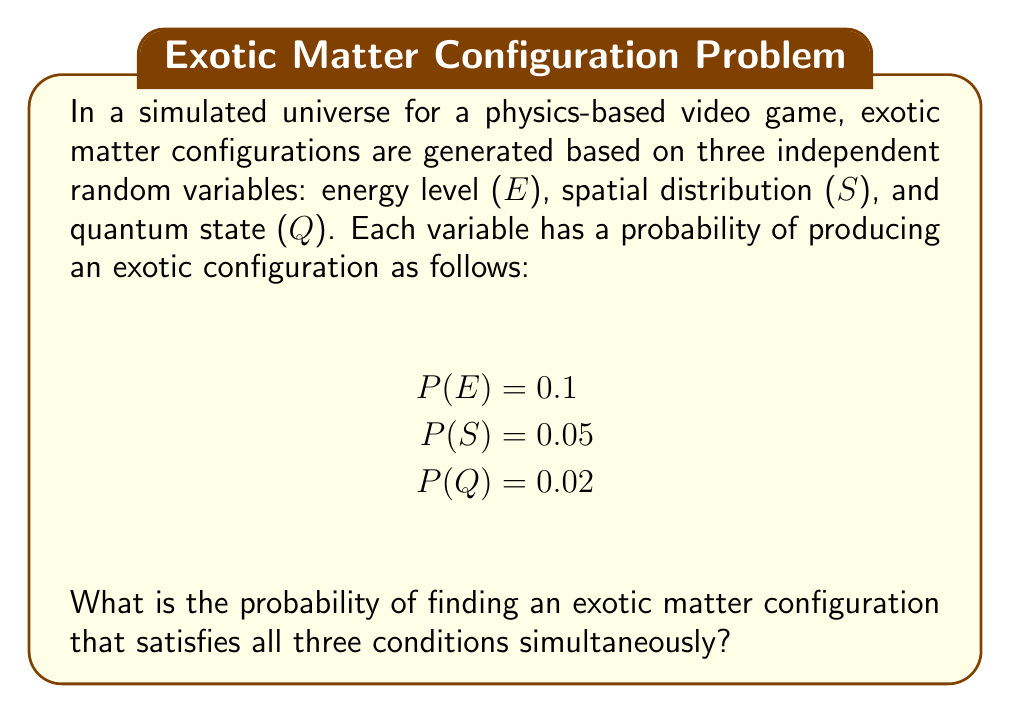Show me your answer to this math problem. To solve this problem, we'll follow these steps:

1. Recognize that we're dealing with independent events.
2. Recall the multiplication rule for independent events.
3. Apply the rule to our given probabilities.

Step 1: Independent Events
The question states that the three random variables (E, S, and Q) are independent. This means that the occurrence of one does not affect the probability of the others.

Step 2: Multiplication Rule for Independent Events
For independent events A, B, and C, the probability of all events occurring simultaneously is given by:

$$ P(A \cap B \cap C) = P(A) \times P(B) \times P(C) $$

Step 3: Apply the Rule
Let's substitute our given probabilities into this formula:

$$ P(\text{Exotic Configuration}) = P(E) \times P(S) \times P(Q) $$
$$ = 0.1 \times 0.05 \times 0.02 $$
$$ = 0.0001 $$

Therefore, the probability of finding an exotic matter configuration that satisfies all three conditions simultaneously is 0.0001 or 1 in 10,000.
Answer: 0.0001 